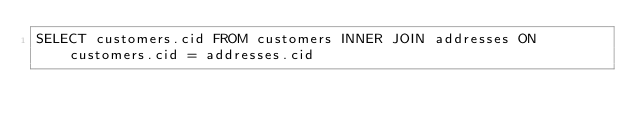<code> <loc_0><loc_0><loc_500><loc_500><_SQL_>SELECT customers.cid FROM customers INNER JOIN addresses ON customers.cid = addresses.cid</code> 